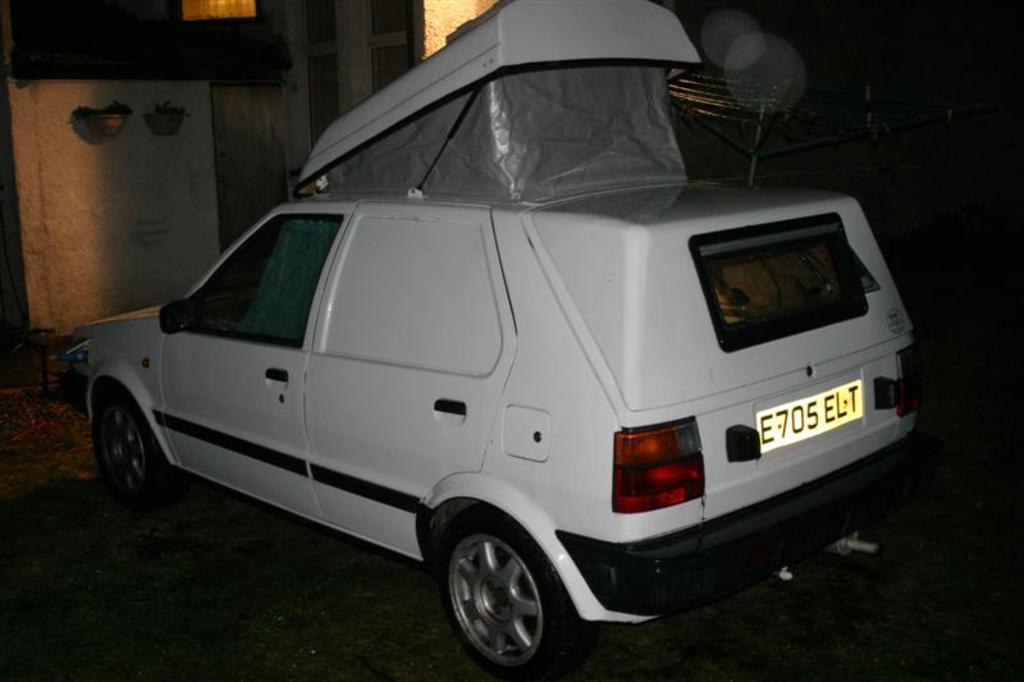Can you describe this image briefly? In the picture we can see a car which is parked near the wall, and the car is white in color and some modified part of it and to the wall we can see some house plants are hung to the roof. 